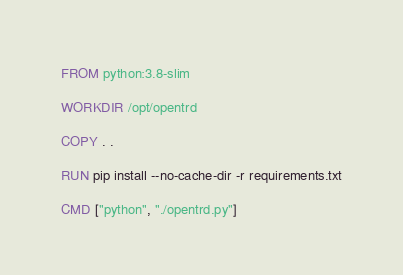<code> <loc_0><loc_0><loc_500><loc_500><_Dockerfile_>FROM python:3.8-slim

WORKDIR /opt/opentrd

COPY . .

RUN pip install --no-cache-dir -r requirements.txt

CMD ["python", "./opentrd.py"]</code> 